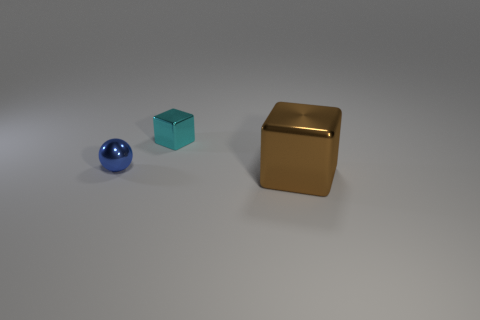Add 1 cylinders. How many objects exist? 4 Subtract all cubes. How many objects are left? 1 Subtract 0 brown cylinders. How many objects are left? 3 Subtract all small blue cubes. Subtract all small cyan cubes. How many objects are left? 2 Add 2 tiny cyan objects. How many tiny cyan objects are left? 3 Add 3 big brown shiny objects. How many big brown shiny objects exist? 4 